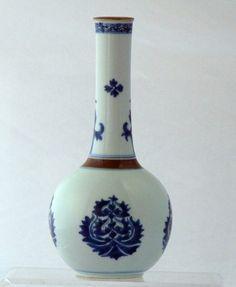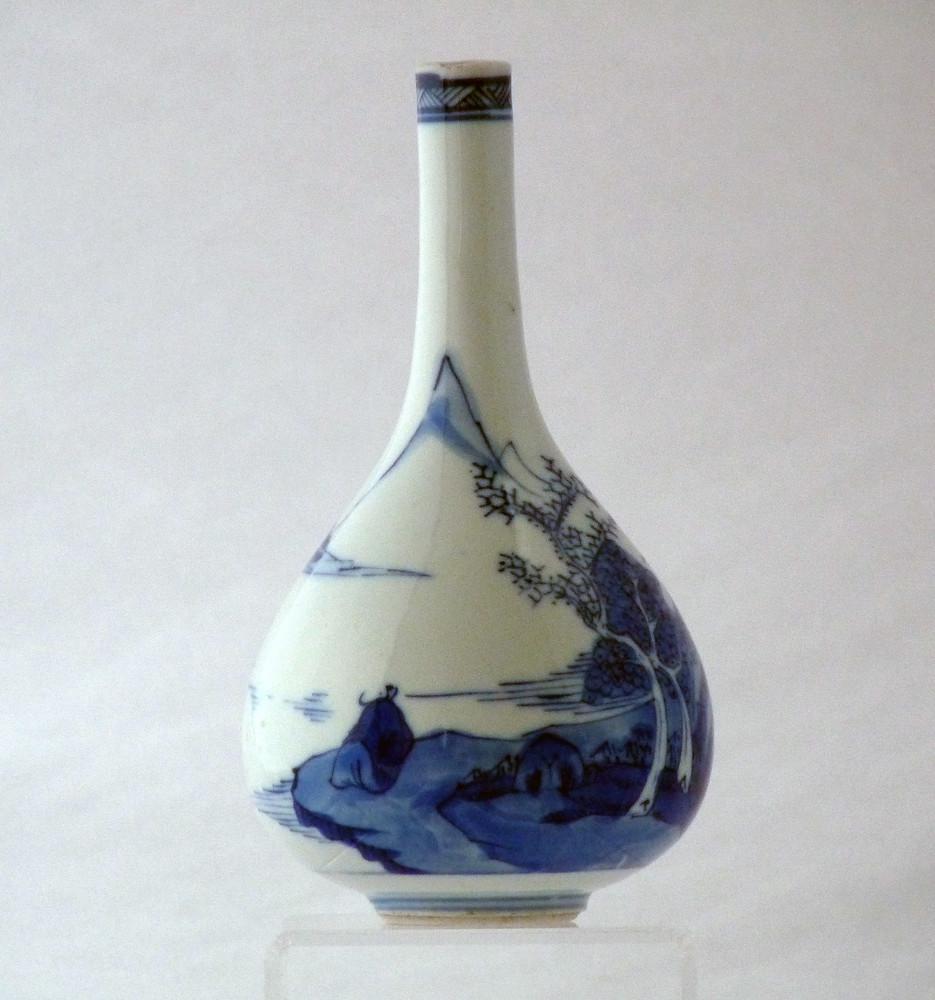The first image is the image on the left, the second image is the image on the right. For the images shown, is this caption "Each image contains a single white vase with blue decoration, and no vase has a cover." true? Answer yes or no. Yes. 